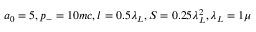<formula> <loc_0><loc_0><loc_500><loc_500>a _ { 0 } = 5 , p _ { - } = 1 0 m c , l = 0 . 5 \lambda _ { L } , S = 0 . 2 5 \lambda _ { L } ^ { 2 } , \lambda _ { L } = 1 \mu</formula> 